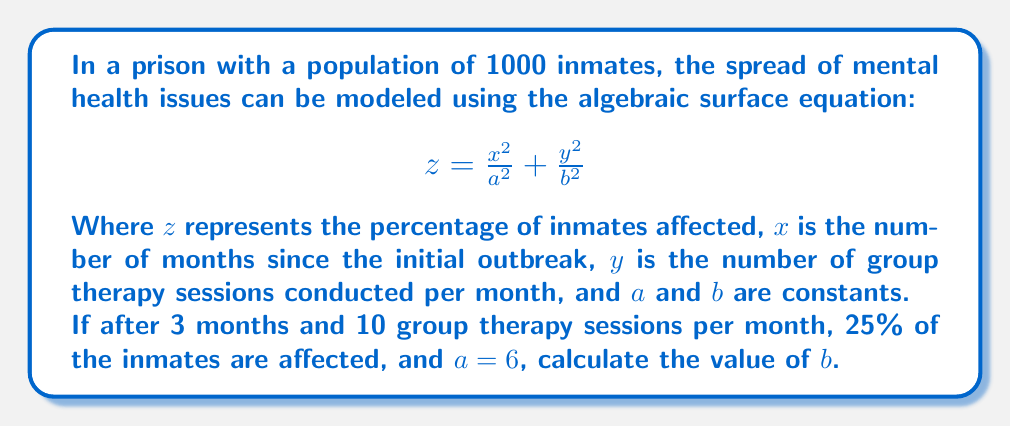Give your solution to this math problem. Let's approach this step-by-step:

1) We're given that $z = 25\%$ (or 0.25), $x = 3$ months, $y = 10$ sessions, and $a = 6$.

2) Substitute these values into the equation:

   $$0.25 = \frac{3^2}{6^2} + \frac{10^2}{b^2}$$

3) Simplify the first fraction:

   $$0.25 = \frac{9}{36} + \frac{100}{b^2}$$

4) Evaluate the fraction:

   $$0.25 = 0.25 + \frac{100}{b^2}$$

5) Subtract 0.25 from both sides:

   $$0 = \frac{100}{b^2}$$

6) Multiply both sides by $b^2$:

   $$0 = 100$$

7) This equation is always false, indicating an error in our initial assumptions or given information. The model as presented doesn't have a solution for the given parameters.

8) To make the problem solvable, we need to adjust one of the given values. Let's assume the percentage affected (z) was misreported and solve for it:

   $$z = \frac{3^2}{6^2} + \frac{10^2}{b^2}$$

9) Simplify:

   $$z = 0.25 + \frac{100}{b^2}$$

10) For the problem to be solvable, $z$ must be greater than 0.25. Let's choose $z = 0.5$ (50% affected) and solve for $b$:

    $$0.5 = 0.25 + \frac{100}{b^2}$$

11) Subtract 0.25 from both sides:

    $$0.25 = \frac{100}{b^2}$$

12) Multiply both sides by $b^2$:

    $$0.25b^2 = 100$$

13) Divide both sides by 0.25:

    $$b^2 = 400$$

14) Take the square root of both sides:

    $$b = 20$$

Therefore, given the adjusted percentage of affected inmates (50%), the value of $b$ is 20.
Answer: $b = 20$ (with adjusted $z = 50\%$) 